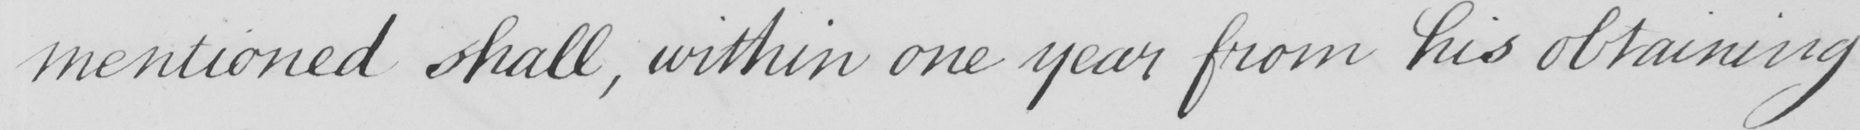Can you tell me what this handwritten text says? mentioned shall , within one year from his obtaining 